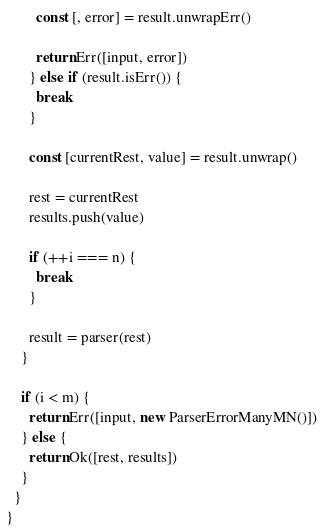<code> <loc_0><loc_0><loc_500><loc_500><_TypeScript_>        const [, error] = result.unwrapErr()

        return Err([input, error])
      } else if (result.isErr()) {
        break
      }

      const [currentRest, value] = result.unwrap()

      rest = currentRest
      results.push(value)

      if (++i === n) {
        break
      }

      result = parser(rest)
    }

    if (i < m) {
      return Err([input, new ParserErrorManyMN()])
    } else {
      return Ok([rest, results])
    }
  }
}
</code> 